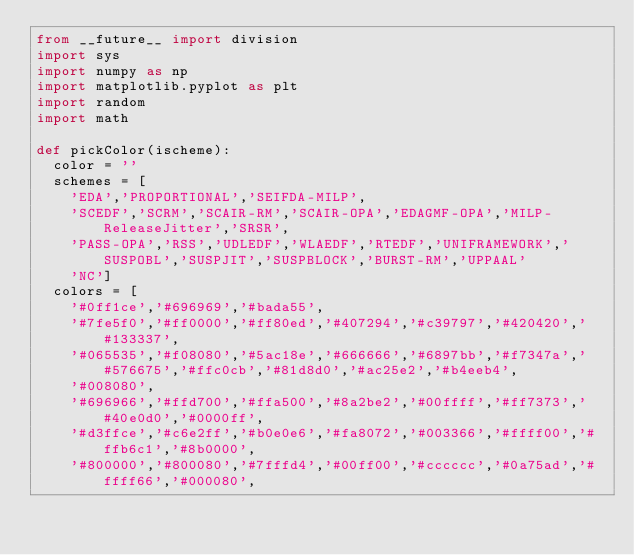<code> <loc_0><loc_0><loc_500><loc_500><_Python_>from __future__ import division
import sys
import numpy as np
import matplotlib.pyplot as plt
import random
import math

def pickColor(ischeme):
	color = ''
	schemes = [
		'EDA','PROPORTIONAL','SEIFDA-MILP',
		'SCEDF','SCRM','SCAIR-RM','SCAIR-OPA','EDAGMF-OPA','MILP-ReleaseJitter','SRSR',
		'PASS-OPA','RSS','UDLEDF','WLAEDF','RTEDF','UNIFRAMEWORK','SUSPOBL','SUSPJIT','SUSPBLOCK','BURST-RM','UPPAAL'
		'NC']
	colors = [
		'#0ff1ce','#696969','#bada55',
		'#7fe5f0','#ff0000','#ff80ed','#407294','#c39797','#420420','#133337',
		'#065535','#f08080','#5ac18e','#666666','#6897bb','#f7347a','#576675','#ffc0cb','#81d8d0','#ac25e2','#b4eeb4',
		'#008080',
		'#696966','#ffd700','#ffa500','#8a2be2','#00ffff','#ff7373','#40e0d0','#0000ff',
		'#d3ffce','#c6e2ff','#b0e0e6','#fa8072','#003366','#ffff00','#ffb6c1','#8b0000',
		'#800000','#800080','#7fffd4','#00ff00','#cccccc','#0a75ad','#ffff66','#000080',</code> 